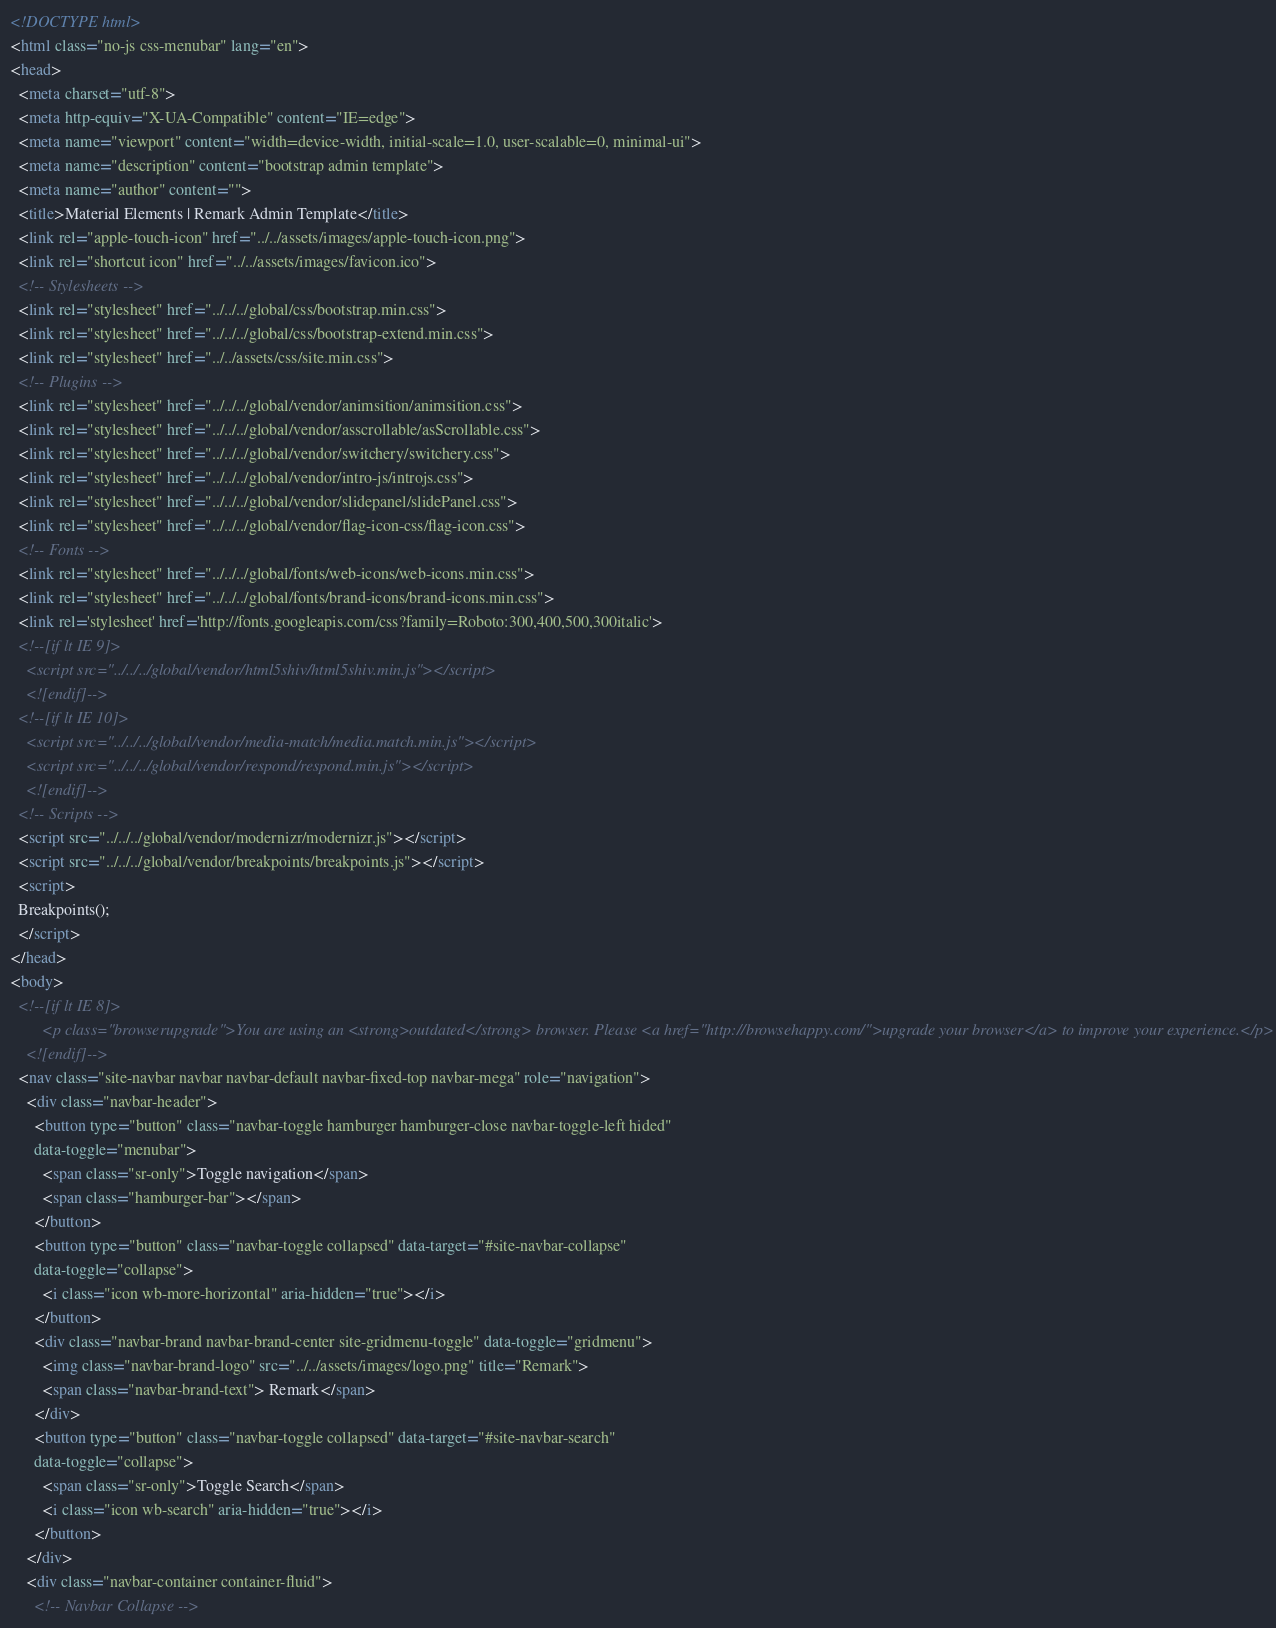Convert code to text. <code><loc_0><loc_0><loc_500><loc_500><_HTML_><!DOCTYPE html>
<html class="no-js css-menubar" lang="en">
<head>
  <meta charset="utf-8">
  <meta http-equiv="X-UA-Compatible" content="IE=edge">
  <meta name="viewport" content="width=device-width, initial-scale=1.0, user-scalable=0, minimal-ui">
  <meta name="description" content="bootstrap admin template">
  <meta name="author" content="">
  <title>Material Elements | Remark Admin Template</title>
  <link rel="apple-touch-icon" href="../../assets/images/apple-touch-icon.png">
  <link rel="shortcut icon" href="../../assets/images/favicon.ico">
  <!-- Stylesheets -->
  <link rel="stylesheet" href="../../../global/css/bootstrap.min.css">
  <link rel="stylesheet" href="../../../global/css/bootstrap-extend.min.css">
  <link rel="stylesheet" href="../../assets/css/site.min.css">
  <!-- Plugins -->
  <link rel="stylesheet" href="../../../global/vendor/animsition/animsition.css">
  <link rel="stylesheet" href="../../../global/vendor/asscrollable/asScrollable.css">
  <link rel="stylesheet" href="../../../global/vendor/switchery/switchery.css">
  <link rel="stylesheet" href="../../../global/vendor/intro-js/introjs.css">
  <link rel="stylesheet" href="../../../global/vendor/slidepanel/slidePanel.css">
  <link rel="stylesheet" href="../../../global/vendor/flag-icon-css/flag-icon.css">
  <!-- Fonts -->
  <link rel="stylesheet" href="../../../global/fonts/web-icons/web-icons.min.css">
  <link rel="stylesheet" href="../../../global/fonts/brand-icons/brand-icons.min.css">
  <link rel='stylesheet' href='http://fonts.googleapis.com/css?family=Roboto:300,400,500,300italic'>
  <!--[if lt IE 9]>
    <script src="../../../global/vendor/html5shiv/html5shiv.min.js"></script>
    <![endif]-->
  <!--[if lt IE 10]>
    <script src="../../../global/vendor/media-match/media.match.min.js"></script>
    <script src="../../../global/vendor/respond/respond.min.js"></script>
    <![endif]-->
  <!-- Scripts -->
  <script src="../../../global/vendor/modernizr/modernizr.js"></script>
  <script src="../../../global/vendor/breakpoints/breakpoints.js"></script>
  <script>
  Breakpoints();
  </script>
</head>
<body>
  <!--[if lt IE 8]>
        <p class="browserupgrade">You are using an <strong>outdated</strong> browser. Please <a href="http://browsehappy.com/">upgrade your browser</a> to improve your experience.</p>
    <![endif]-->
  <nav class="site-navbar navbar navbar-default navbar-fixed-top navbar-mega" role="navigation">
    <div class="navbar-header">
      <button type="button" class="navbar-toggle hamburger hamburger-close navbar-toggle-left hided"
      data-toggle="menubar">
        <span class="sr-only">Toggle navigation</span>
        <span class="hamburger-bar"></span>
      </button>
      <button type="button" class="navbar-toggle collapsed" data-target="#site-navbar-collapse"
      data-toggle="collapse">
        <i class="icon wb-more-horizontal" aria-hidden="true"></i>
      </button>
      <div class="navbar-brand navbar-brand-center site-gridmenu-toggle" data-toggle="gridmenu">
        <img class="navbar-brand-logo" src="../../assets/images/logo.png" title="Remark">
        <span class="navbar-brand-text"> Remark</span>
      </div>
      <button type="button" class="navbar-toggle collapsed" data-target="#site-navbar-search"
      data-toggle="collapse">
        <span class="sr-only">Toggle Search</span>
        <i class="icon wb-search" aria-hidden="true"></i>
      </button>
    </div>
    <div class="navbar-container container-fluid">
      <!-- Navbar Collapse --></code> 